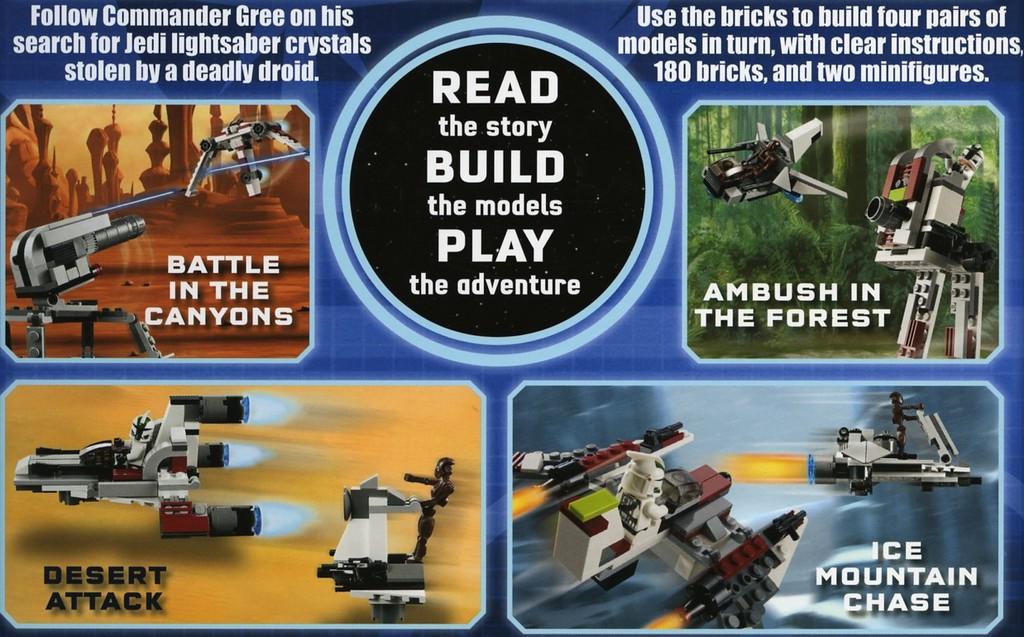What is the name of the one with the orange background?
Provide a short and direct response. Desert attack. This some battlle game?
Provide a short and direct response. Yes. 